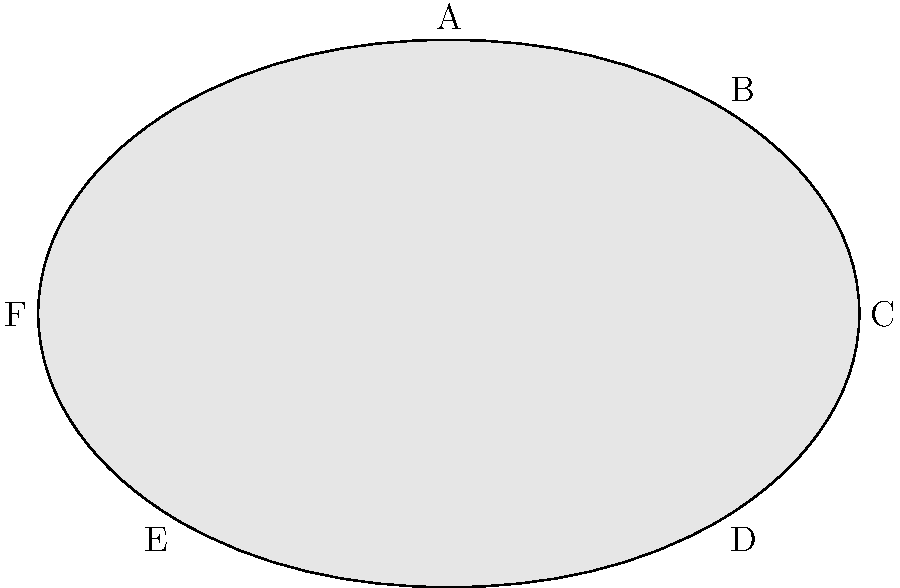As a stable hand, you're tasked with identifying different parts of a horse's anatomy. Using the labeled diagram above, which letter corresponds to the withers of the horse? To answer this question, let's go through the parts of the horse's anatomy step-by-step:

1. The withers is the highest point of a horse's back, located at the base of the neck where it meets the back.

2. Looking at the diagram:
   A: This point is at the highest part of the horse's back, where the neck meets the body.
   B: This appears to be the horse's shoulder area.
   C: This is likely the hip or croup area.
   D: This could be the stifle or thigh region.
   E: This is probably the front leg or chest area.
   F: This seems to be the head or neck region.

3. Based on the definition of withers and the location in the diagram, we can conclude that the point labeled "A" corresponds to the withers of the horse.

4. As a stable hand working closely with horses, it's crucial to know this part of the anatomy as it's often used as a reference point for measuring a horse's height and fitting equipment like saddles.
Answer: A 